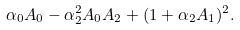Convert formula to latex. <formula><loc_0><loc_0><loc_500><loc_500>\alpha _ { 0 } A _ { 0 } - \alpha _ { 2 } ^ { 2 } A _ { 0 } A _ { 2 } + ( 1 + \alpha _ { 2 } A _ { 1 } ) ^ { 2 } .</formula> 